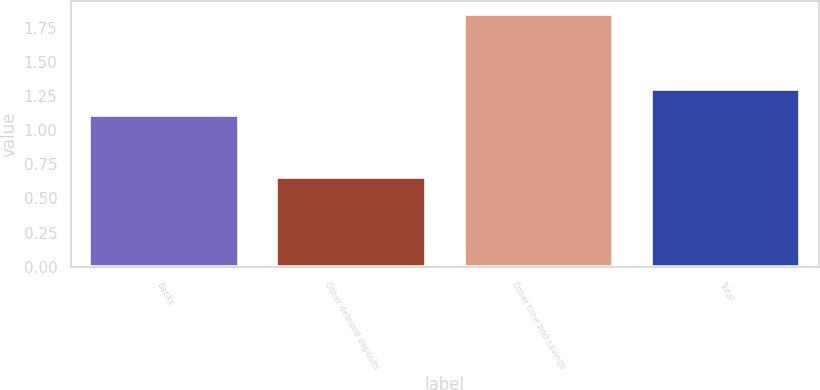<chart> <loc_0><loc_0><loc_500><loc_500><bar_chart><fcel>Banks<fcel>Other demand deposits<fcel>Other time and savings<fcel>Total<nl><fcel>1.11<fcel>0.66<fcel>1.85<fcel>1.3<nl></chart> 